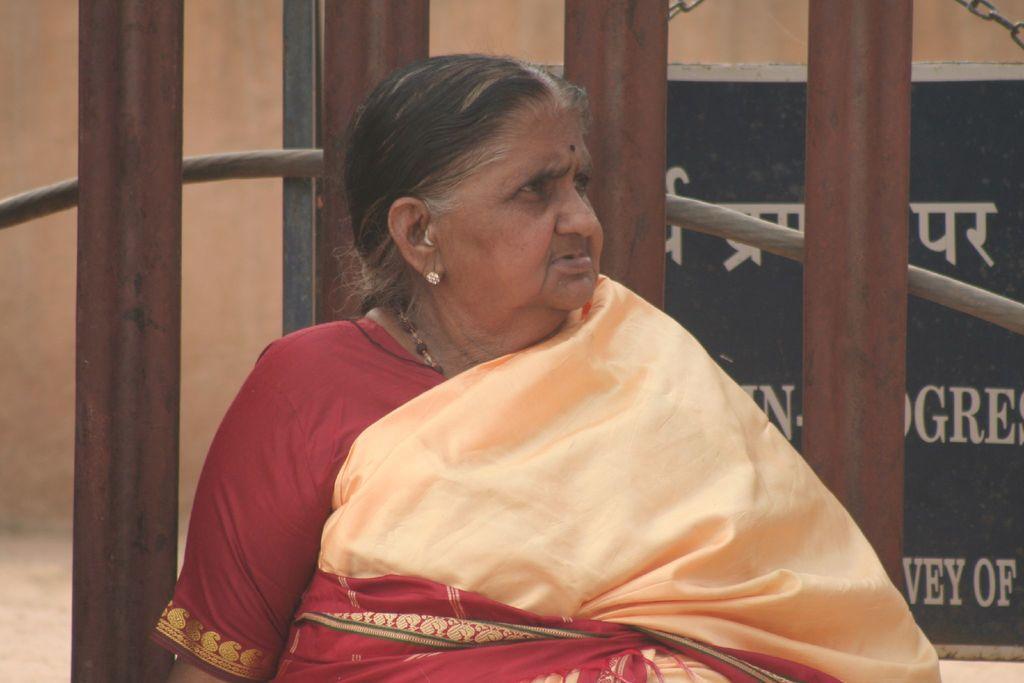In one or two sentences, can you explain what this image depicts? In the image we can see there is a woman standing and she is wearing saari. Behind her there are iron rods. 